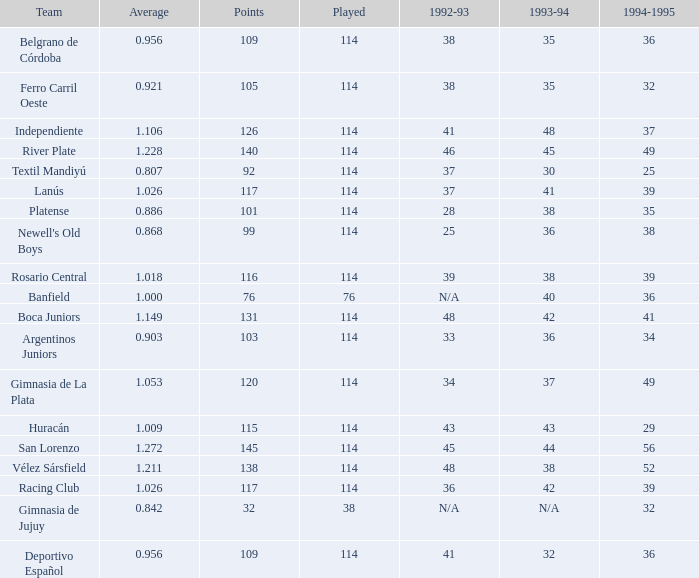Name the total number of 1992-93 for 115 points 1.0. 